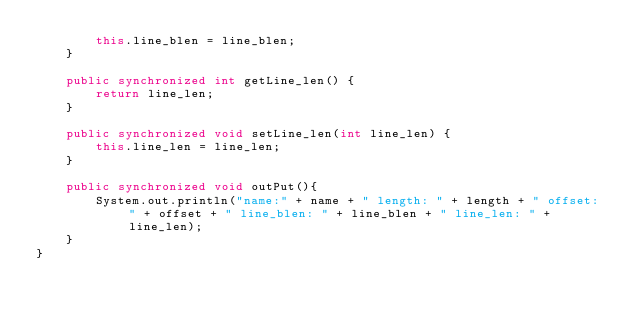<code> <loc_0><loc_0><loc_500><loc_500><_Java_>        this.line_blen = line_blen;
    }

    public synchronized int getLine_len() {
        return line_len;
    }

    public synchronized void setLine_len(int line_len) {
        this.line_len = line_len;
    }

    public synchronized void outPut(){
        System.out.println("name:" + name + " length: " + length + " offset: " + offset + " line_blen: " + line_blen + " line_len: " + line_len);
    }
}
</code> 